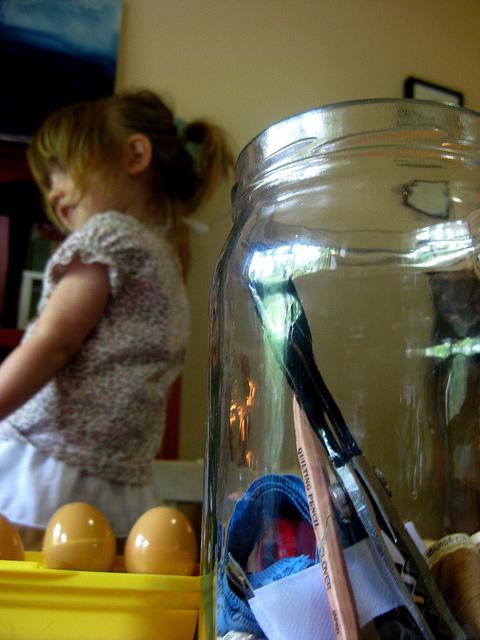What is the glass jar holding?
Write a very short answer. Scissors. What hairstyle is the girl wearing?
Be succinct. Ponytail. What is in the yellow bucket?
Concise answer only. Eggs. 